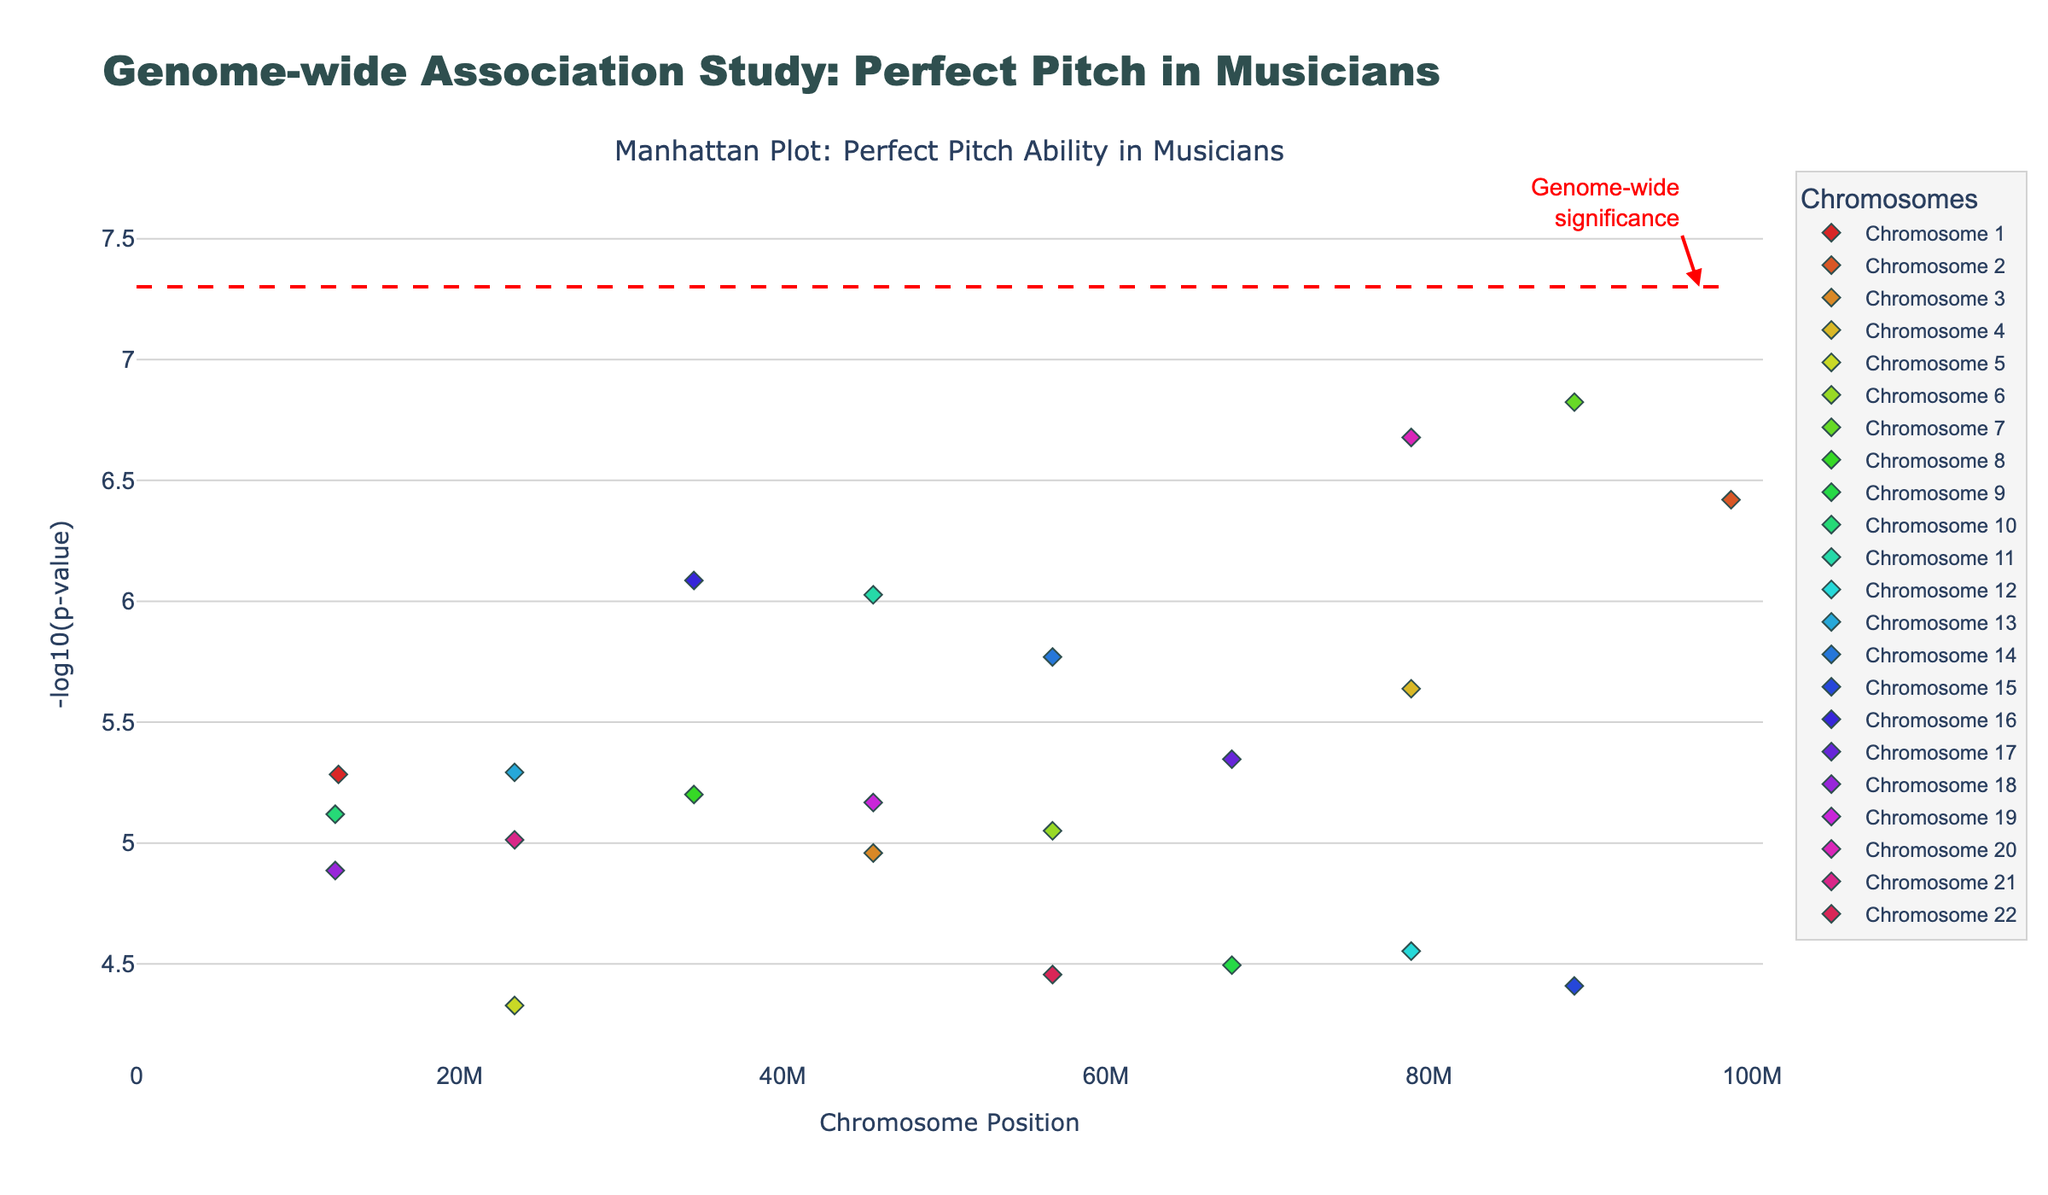What is the title of the plot? The title of the plot is located at the top center and reads "Genome-wide Association Study: Perfect Pitch in Musicians".
Answer: Genome-wide Association Study: Perfect Pitch in Musicians What does the y-axis represent? The y-axis is labeled as "-log10(p-value)", indicating it shows the negative logarithm base 10 of the p-values.
Answer: -log10(p-value) Which chromosome has the data point with the smallest p-value? The smallest p-value will have the highest -log10(p-value) value on the y-axis. By finding the highest marker, it corresponds to Chromosome 2.
Answer: Chromosome 2 How many chromosomes have data points with a p-value smaller than 5e-7? By locating data points above the significance line (-log10(5e-8)), Chromosomes 2, 7, 11, 16, and 20 have markers above this line.
Answer: 5 chromosomes What is the color used to represent Chromosome 7? Each chromosome is represented by a different color in the HSL color map. Chromosome 7 is depicted with a distinct color among the other chromosomes.
Answer: (description based on actual plot colors) Which chromosome(s) have SNPs with a p-value between 1e-6 and 1e-5? Locate -log10(p-value) markers between roughly 6 and 7 on the y-axis (since -log10(1e-6) ≈ 6 and -log10(1e-5) ≈ 5) and identify their respective chromosomes. Chromosomes 1, 4, 6, 8, 10, 13, 14, and 21 have such SNPs.
Answer: Chromosomes 1, 4, 6, 8, 10, 13, 14, 21 How many data points are there for Chromosome 20? Check the number of markers specifically for Chromosome 20 on the plot. In the provided data, Chromosome 20 has one data point.
Answer: 1 data point Which SNP has the highest -log10(p-value) and what chromosome is it on? The highest -log10(p-value) corresponds to the smallest p-value. The SNP rs2274305 on Chromosome 2 has the highest -log10(p-value).
Answer: rs2274305 on Chromosome 2 How does the -log10(p-value) for SNP rs1800497 compare to the genome-wide significance line? Find the SNP rs1800497 on Chromosome 20, compare its position on the y-axis to the significance line at -log10(5e-8). It is above the line, meaning it is above the genome-wide significance threshold.
Answer: Above the significance line 